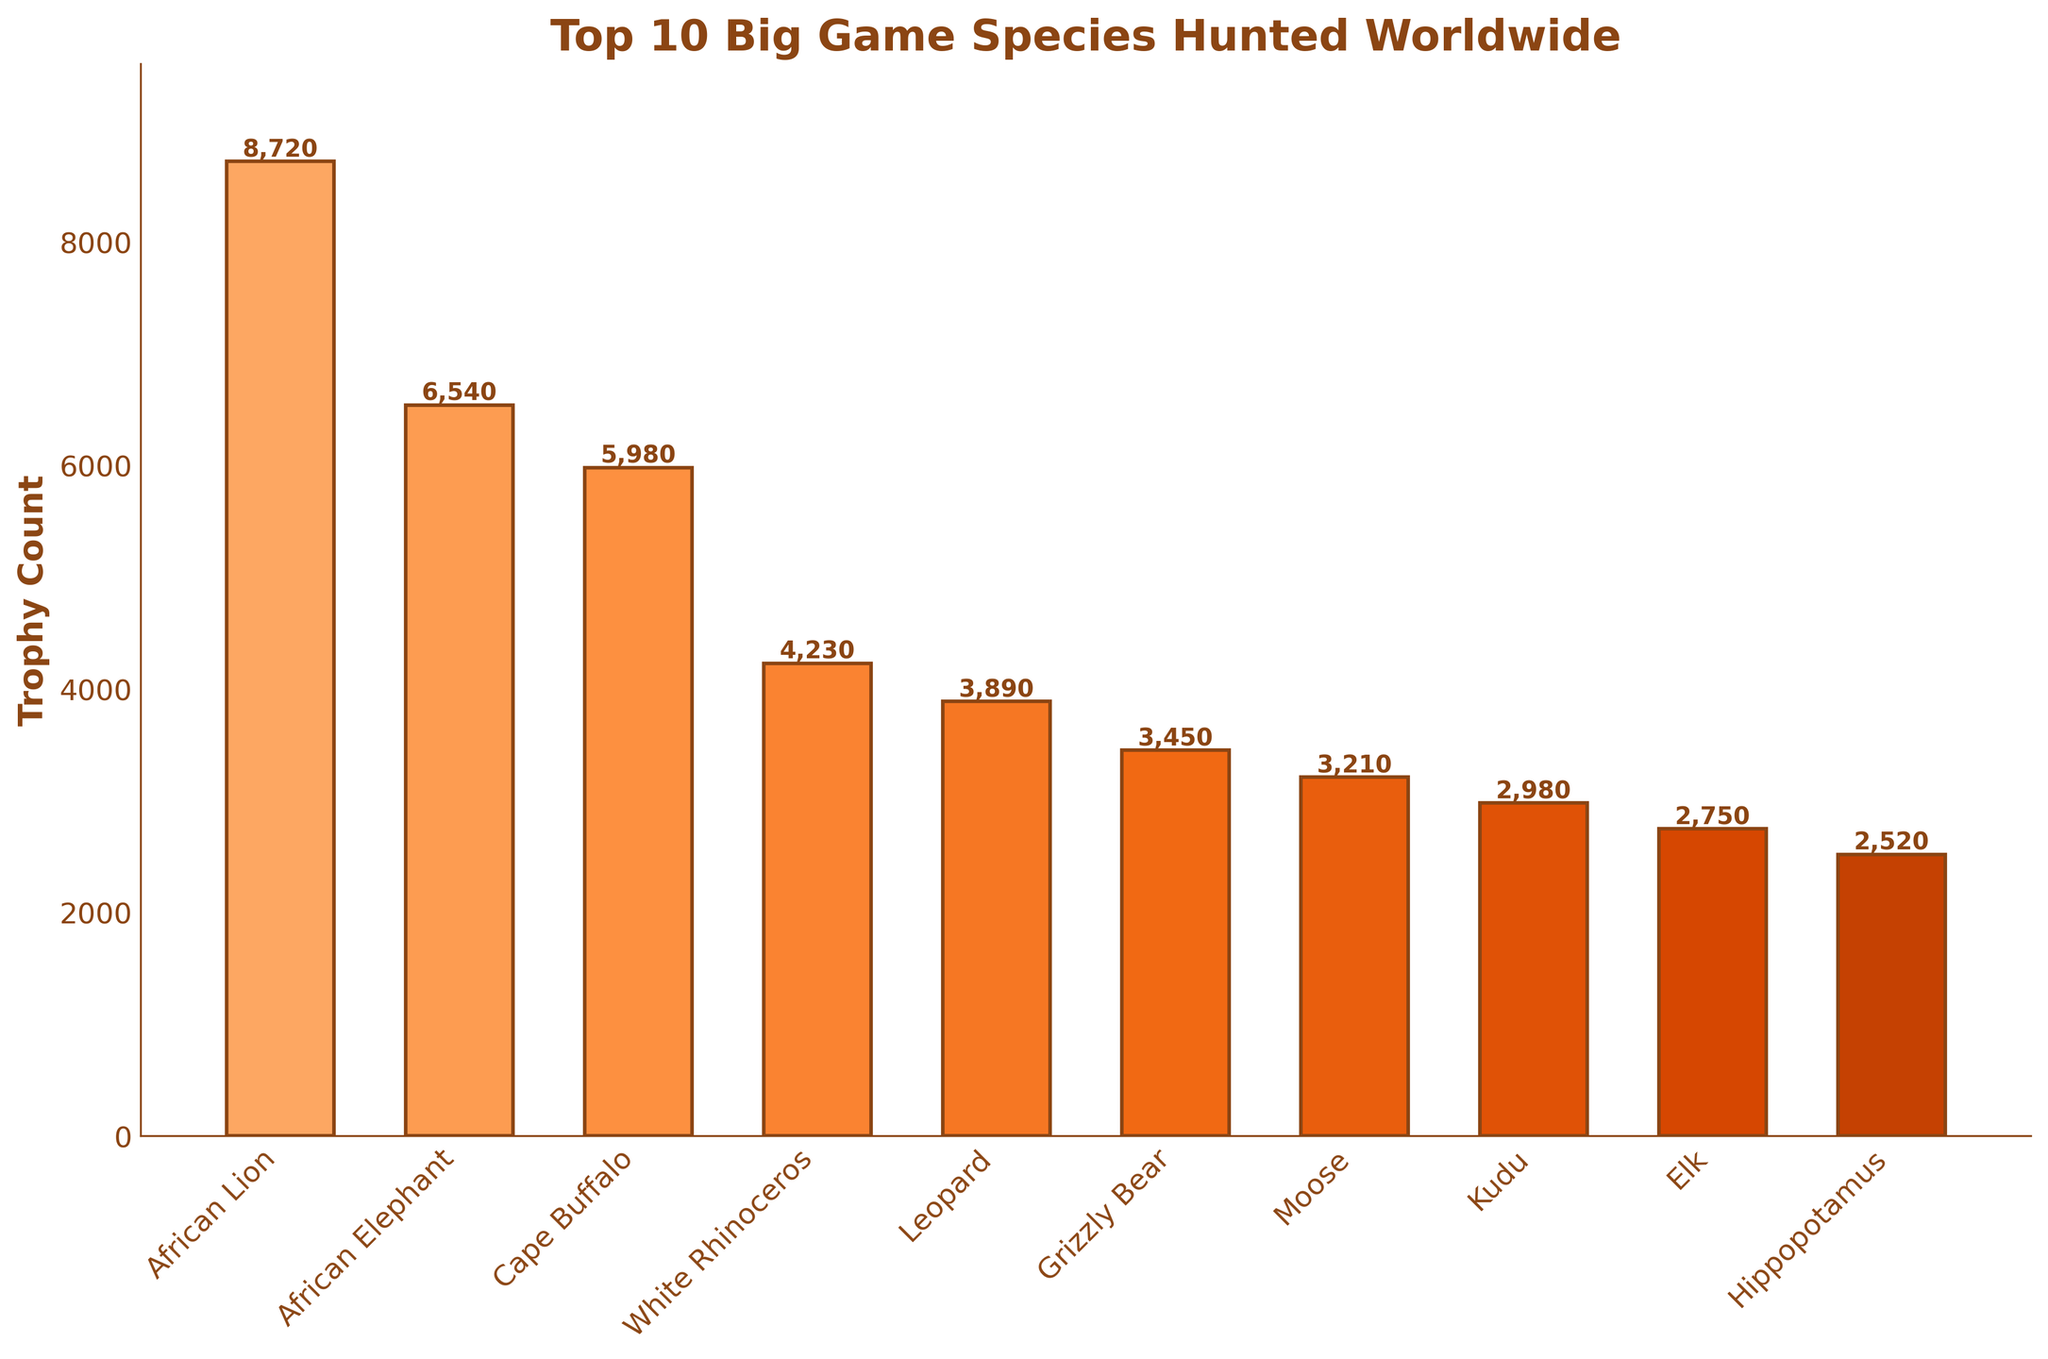What is the total trophy count for the top 3 big game species? Add the trophy counts for African Lion, African Elephant, and Cape Buffalo: 8720 + 6540 + 5980 = 21240.
Answer: 21240 Which species has a higher trophy count, the Grizzly Bear or the Hippopotamus? Compare the trophy counts for Grizzly Bear (3450) and Hippopotamus (2520). The Grizzly Bear has a higher count.
Answer: Grizzly Bear How many more trophies does the African Lion have compared to the Moose? Subtract the trophy count of the Moose from the African Lion: 8720 - 3210 = 5510.
Answer: 5510 By how much does the sum of the top 5 species' trophy counts exceed the sum of the bottom 5 species'? Add the trophy counts of the top 5 species (8720 + 6540 + 5980 + 4230 + 3890 = 29360) and the bottom 5 species (3450 + 3210 + 2980 + 2750 + 2520 = 14910). Subtract the bottom 5 total from the top 5 total: 29360 - 14910 = 14450.
Answer: 14450 What is the average trophy count of all the species listed? Sum all trophy counts and divide by the number of species: (8720 + 6540 + 5980 + 4230 + 3890 + 3450 + 3210 + 2980 + 2750 + 2520) / 10 = 44270 / 10 = 4427.
Answer: 4427 Which species has the longest bar on the chart? The African Lion has the highest trophy count (8720) and thus the longest bar on the chart.
Answer: African Lion What is the difference in trophy count between the White Rhinoceros and the Kudu? Subtract the Kudu's count from the White Rhinoceros's count: 4230 - 2980 = 1250.
Answer: 1250 Which species has the shortest bar on the chart? The Hippopotamus has the lowest trophy count (2520) and thus the shortest bar on the chart.
Answer: Hippopotamus How much higher is the trophy count of the African Elephant compared to the Elk? Subtract the trophy count of the Elk from the African Elephant: 6540 - 2750 = 3790.
Answer: 3790 